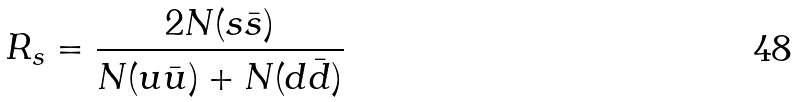Convert formula to latex. <formula><loc_0><loc_0><loc_500><loc_500>R _ { s } = \frac { 2 N ( s \bar { s } ) } { N ( u \bar { u } ) + N ( d \bar { d } ) }</formula> 